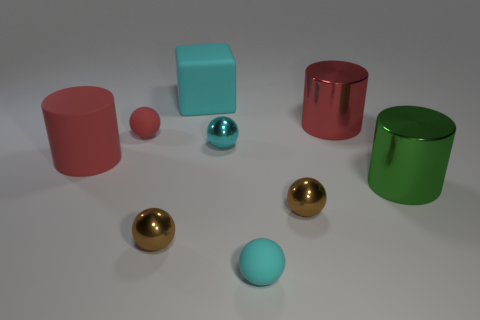What number of things are both behind the green object and to the left of the big cyan thing?
Your answer should be compact. 2. How many spheres are matte things or big red things?
Provide a short and direct response. 2. Are any tiny red matte cylinders visible?
Your answer should be very brief. No. How many other things are there of the same material as the red ball?
Ensure brevity in your answer.  3. What material is the red thing that is the same size as the cyan matte sphere?
Your response must be concise. Rubber. Do the tiny metal thing that is left of the cyan cube and the big cyan object have the same shape?
Make the answer very short. No. Is the color of the big matte cube the same as the rubber cylinder?
Your answer should be very brief. No. What number of things are metal things on the right side of the big cyan block or red matte cylinders?
Your answer should be very brief. 5. What shape is the cyan metal object that is the same size as the red rubber ball?
Offer a very short reply. Sphere. There is a rubber sphere on the left side of the small cyan shiny sphere; is its size the same as the shiny cylinder in front of the red metallic object?
Your answer should be compact. No. 